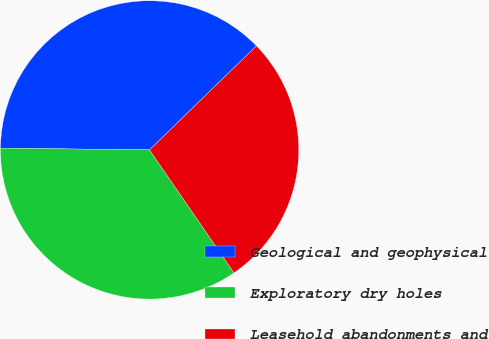Convert chart. <chart><loc_0><loc_0><loc_500><loc_500><pie_chart><fcel>Geological and geophysical<fcel>Exploratory dry holes<fcel>Leasehold abandonments and<nl><fcel>37.52%<fcel>34.77%<fcel>27.71%<nl></chart> 